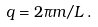<formula> <loc_0><loc_0><loc_500><loc_500>q = 2 \pi m / L \, .</formula> 